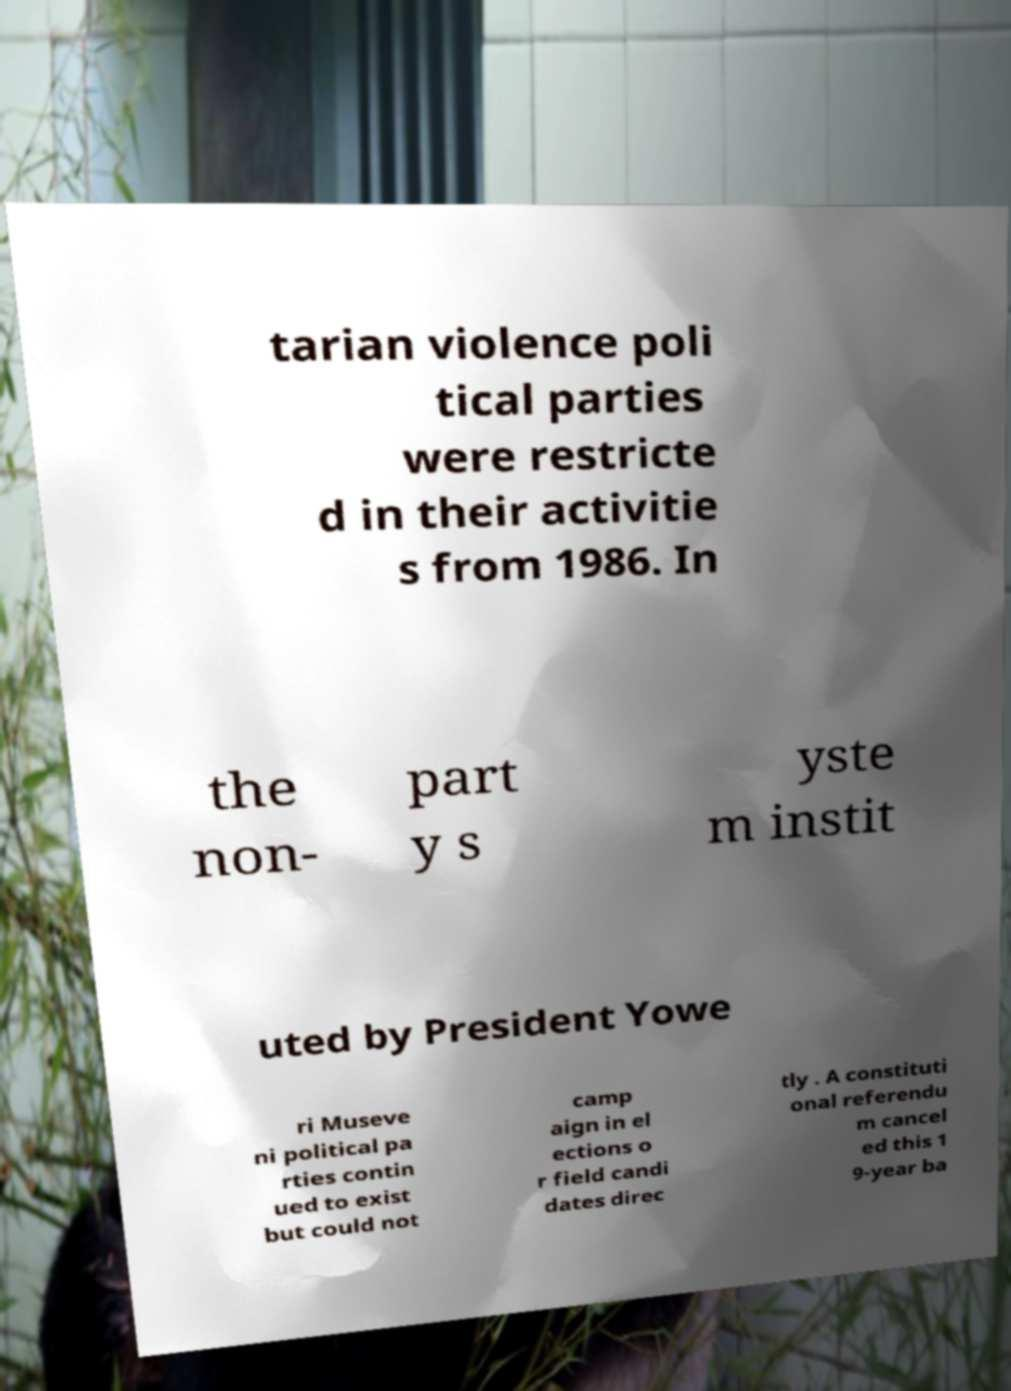Can you read and provide the text displayed in the image?This photo seems to have some interesting text. Can you extract and type it out for me? tarian violence poli tical parties were restricte d in their activitie s from 1986. In the non- part y s yste m instit uted by President Yowe ri Museve ni political pa rties contin ued to exist but could not camp aign in el ections o r field candi dates direc tly . A constituti onal referendu m cancel ed this 1 9-year ba 